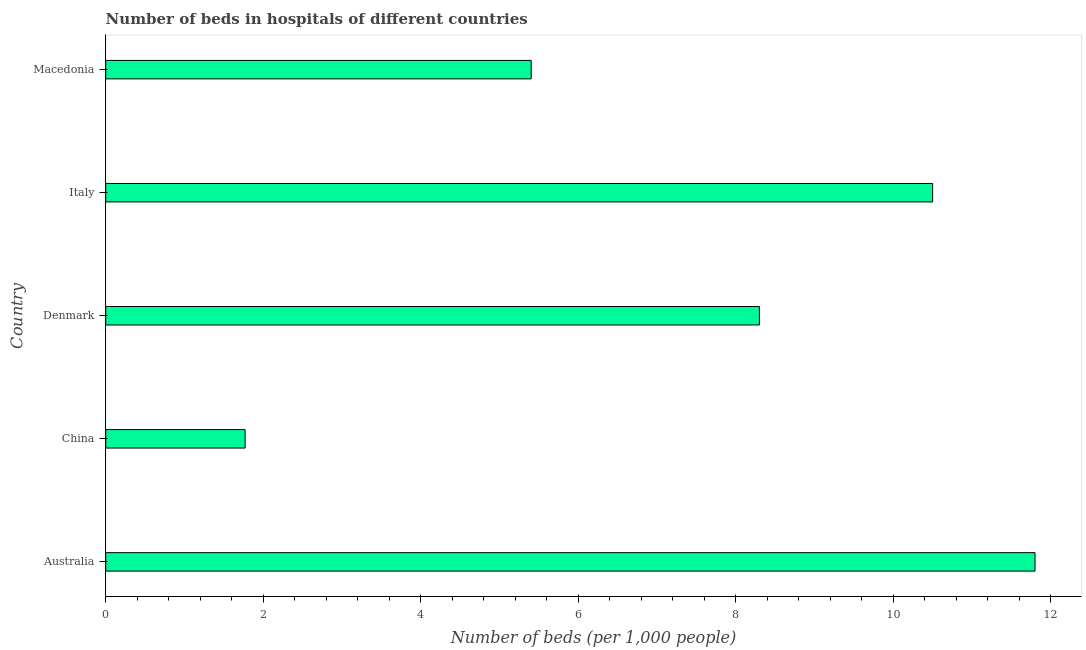What is the title of the graph?
Provide a succinct answer. Number of beds in hospitals of different countries. What is the label or title of the X-axis?
Give a very brief answer. Number of beds (per 1,0 people). What is the number of hospital beds in Australia?
Keep it short and to the point. 11.8. Across all countries, what is the maximum number of hospital beds?
Give a very brief answer. 11.8. Across all countries, what is the minimum number of hospital beds?
Make the answer very short. 1.77. In which country was the number of hospital beds minimum?
Your response must be concise. China. What is the sum of the number of hospital beds?
Offer a terse response. 37.77. What is the average number of hospital beds per country?
Your answer should be compact. 7.55. What is the median number of hospital beds?
Offer a terse response. 8.3. In how many countries, is the number of hospital beds greater than 5.6 %?
Your answer should be very brief. 3. What is the ratio of the number of hospital beds in Italy to that in Macedonia?
Your response must be concise. 1.94. Is the number of hospital beds in China less than that in Italy?
Give a very brief answer. Yes. What is the difference between the highest and the lowest number of hospital beds?
Provide a succinct answer. 10.03. How many bars are there?
Provide a succinct answer. 5. Are all the bars in the graph horizontal?
Make the answer very short. Yes. How many countries are there in the graph?
Make the answer very short. 5. What is the difference between two consecutive major ticks on the X-axis?
Your answer should be compact. 2. Are the values on the major ticks of X-axis written in scientific E-notation?
Your response must be concise. No. What is the Number of beds (per 1,000 people) of Australia?
Your response must be concise. 11.8. What is the Number of beds (per 1,000 people) of China?
Your answer should be compact. 1.77. What is the Number of beds (per 1,000 people) in Denmark?
Keep it short and to the point. 8.3. What is the Number of beds (per 1,000 people) in Macedonia?
Make the answer very short. 5.4. What is the difference between the Number of beds (per 1,000 people) in Australia and China?
Your answer should be very brief. 10.03. What is the difference between the Number of beds (per 1,000 people) in Australia and Macedonia?
Your answer should be compact. 6.4. What is the difference between the Number of beds (per 1,000 people) in China and Denmark?
Keep it short and to the point. -6.53. What is the difference between the Number of beds (per 1,000 people) in China and Italy?
Keep it short and to the point. -8.73. What is the difference between the Number of beds (per 1,000 people) in China and Macedonia?
Make the answer very short. -3.63. What is the difference between the Number of beds (per 1,000 people) in Denmark and Italy?
Your answer should be very brief. -2.2. What is the difference between the Number of beds (per 1,000 people) in Denmark and Macedonia?
Your response must be concise. 2.9. What is the difference between the Number of beds (per 1,000 people) in Italy and Macedonia?
Keep it short and to the point. 5.1. What is the ratio of the Number of beds (per 1,000 people) in Australia to that in China?
Your answer should be very brief. 6.67. What is the ratio of the Number of beds (per 1,000 people) in Australia to that in Denmark?
Your answer should be compact. 1.42. What is the ratio of the Number of beds (per 1,000 people) in Australia to that in Italy?
Make the answer very short. 1.12. What is the ratio of the Number of beds (per 1,000 people) in Australia to that in Macedonia?
Give a very brief answer. 2.18. What is the ratio of the Number of beds (per 1,000 people) in China to that in Denmark?
Ensure brevity in your answer.  0.21. What is the ratio of the Number of beds (per 1,000 people) in China to that in Italy?
Offer a very short reply. 0.17. What is the ratio of the Number of beds (per 1,000 people) in China to that in Macedonia?
Keep it short and to the point. 0.33. What is the ratio of the Number of beds (per 1,000 people) in Denmark to that in Italy?
Ensure brevity in your answer.  0.79. What is the ratio of the Number of beds (per 1,000 people) in Denmark to that in Macedonia?
Offer a terse response. 1.54. What is the ratio of the Number of beds (per 1,000 people) in Italy to that in Macedonia?
Offer a very short reply. 1.94. 